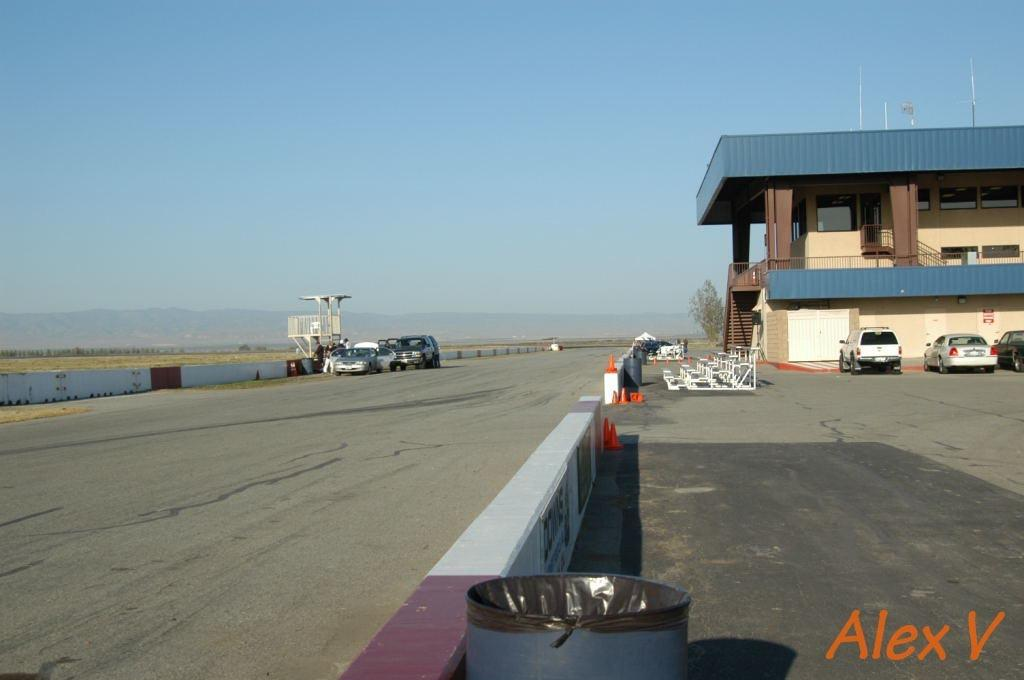What is the main feature of the image? The main feature of the image is a wide area. What can be seen in the wide area? There are vehicles parked in the wide area. What is located on the right side of the image? There is a building on the right side of the image. What can be seen in the background of the image? There is a tree visible in the background of the image. What type of ring can be seen on the tree in the image? There is no ring present on the tree in the image. Can you tell me how many cups are visible in the wide area? There are no cups visible in the wide area in the image. 